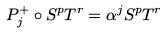<formula> <loc_0><loc_0><loc_500><loc_500>P _ { j } ^ { + } \circ S ^ { p } T ^ { r } = \alpha ^ { j } S ^ { p } T ^ { r }</formula> 